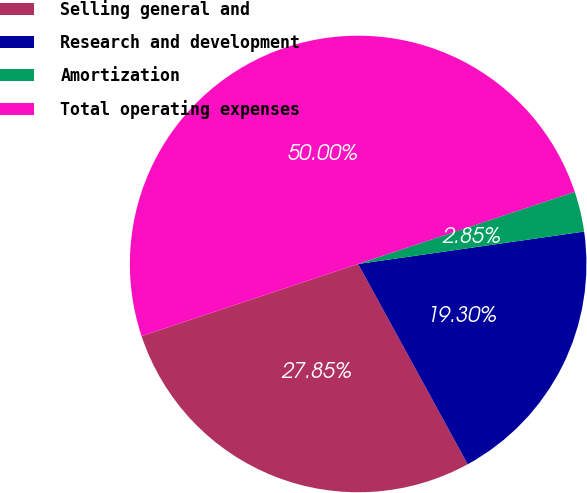Convert chart to OTSL. <chart><loc_0><loc_0><loc_500><loc_500><pie_chart><fcel>Selling general and<fcel>Research and development<fcel>Amortization<fcel>Total operating expenses<nl><fcel>27.85%<fcel>19.3%<fcel>2.85%<fcel>50.0%<nl></chart> 